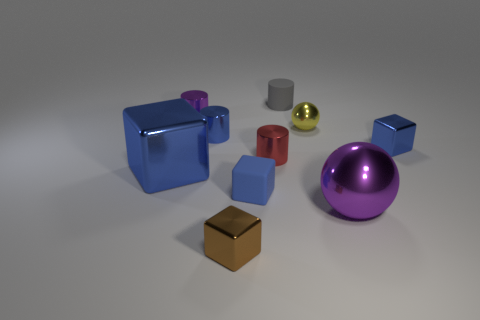Subtract all yellow cylinders. How many blue cubes are left? 3 Subtract 1 cylinders. How many cylinders are left? 3 Subtract all red cubes. Subtract all red balls. How many cubes are left? 4 Subtract all cylinders. How many objects are left? 6 Subtract all small purple shiny cylinders. Subtract all large purple metallic balls. How many objects are left? 8 Add 1 red cylinders. How many red cylinders are left? 2 Add 5 small blue shiny cylinders. How many small blue shiny cylinders exist? 6 Subtract 1 purple cylinders. How many objects are left? 9 